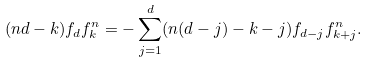<formula> <loc_0><loc_0><loc_500><loc_500>( n d - k ) f _ { d } f ^ { n } _ { k } = - \sum _ { j = 1 } ^ { d } ( n ( d - j ) - k - j ) f _ { d - j } f ^ { n } _ { k + j } .</formula> 